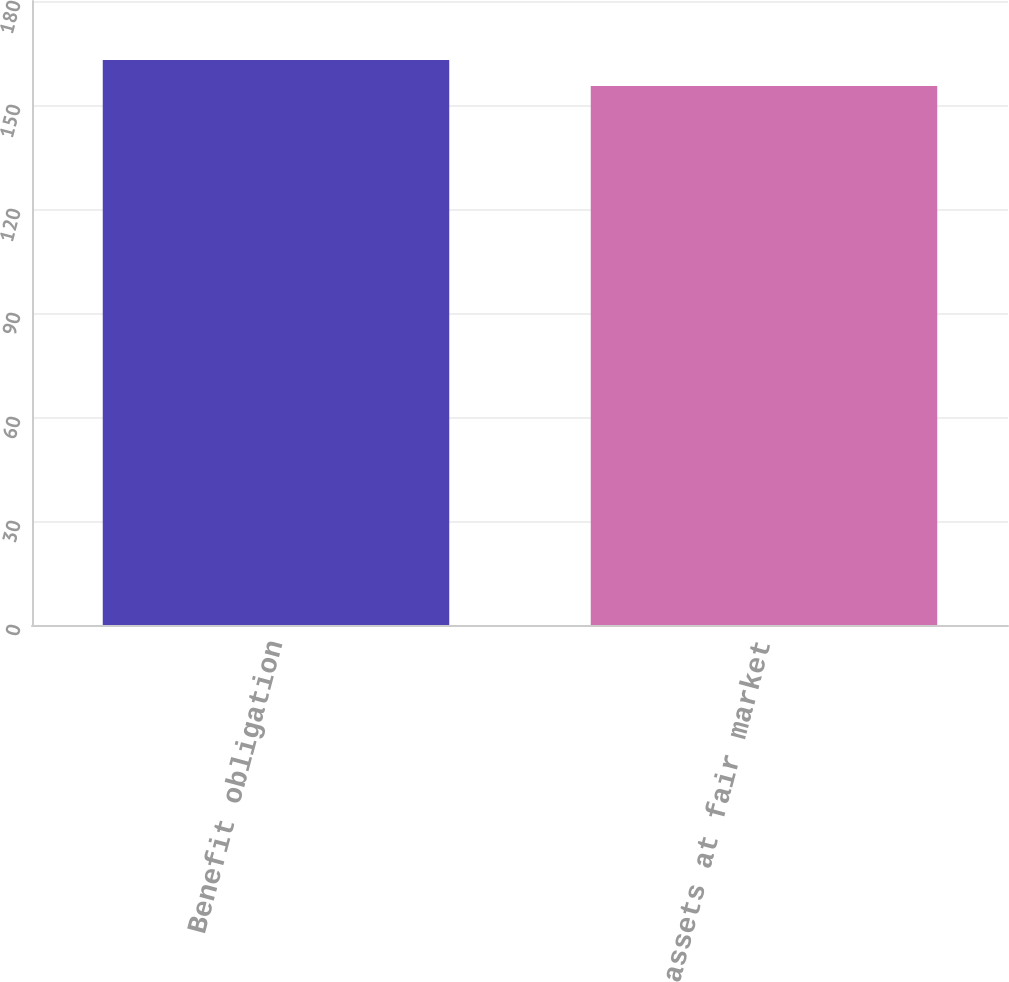Convert chart to OTSL. <chart><loc_0><loc_0><loc_500><loc_500><bar_chart><fcel>Benefit obligation<fcel>Plan assets at fair market<nl><fcel>163<fcel>155.5<nl></chart> 